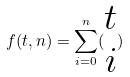<formula> <loc_0><loc_0><loc_500><loc_500>f ( t , n ) = \sum _ { i = 0 } ^ { n } ( \begin{matrix} t \\ i \end{matrix} )</formula> 